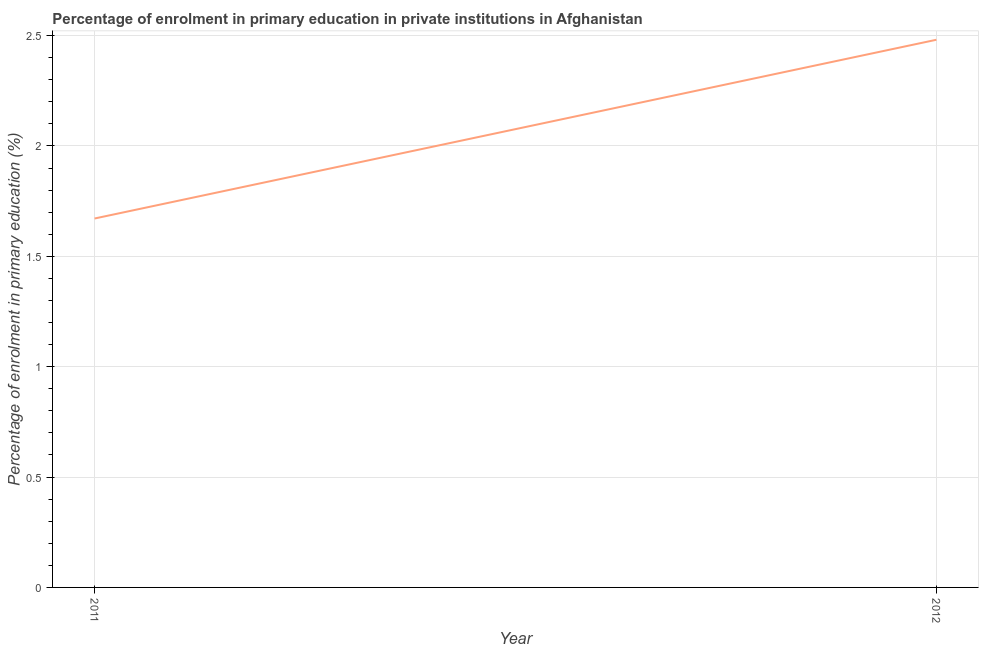What is the enrolment percentage in primary education in 2012?
Give a very brief answer. 2.48. Across all years, what is the maximum enrolment percentage in primary education?
Make the answer very short. 2.48. Across all years, what is the minimum enrolment percentage in primary education?
Ensure brevity in your answer.  1.67. In which year was the enrolment percentage in primary education minimum?
Make the answer very short. 2011. What is the sum of the enrolment percentage in primary education?
Offer a very short reply. 4.15. What is the difference between the enrolment percentage in primary education in 2011 and 2012?
Provide a short and direct response. -0.81. What is the average enrolment percentage in primary education per year?
Keep it short and to the point. 2.08. What is the median enrolment percentage in primary education?
Provide a short and direct response. 2.08. In how many years, is the enrolment percentage in primary education greater than 0.6 %?
Your response must be concise. 2. Do a majority of the years between 2011 and 2012 (inclusive) have enrolment percentage in primary education greater than 0.1 %?
Offer a very short reply. Yes. What is the ratio of the enrolment percentage in primary education in 2011 to that in 2012?
Your response must be concise. 0.67. In how many years, is the enrolment percentage in primary education greater than the average enrolment percentage in primary education taken over all years?
Offer a terse response. 1. Does the enrolment percentage in primary education monotonically increase over the years?
Ensure brevity in your answer.  Yes. How many years are there in the graph?
Offer a very short reply. 2. Are the values on the major ticks of Y-axis written in scientific E-notation?
Your answer should be very brief. No. Does the graph contain any zero values?
Offer a terse response. No. What is the title of the graph?
Offer a very short reply. Percentage of enrolment in primary education in private institutions in Afghanistan. What is the label or title of the Y-axis?
Offer a very short reply. Percentage of enrolment in primary education (%). What is the Percentage of enrolment in primary education (%) of 2011?
Ensure brevity in your answer.  1.67. What is the Percentage of enrolment in primary education (%) of 2012?
Keep it short and to the point. 2.48. What is the difference between the Percentage of enrolment in primary education (%) in 2011 and 2012?
Offer a very short reply. -0.81. What is the ratio of the Percentage of enrolment in primary education (%) in 2011 to that in 2012?
Your answer should be very brief. 0.67. 